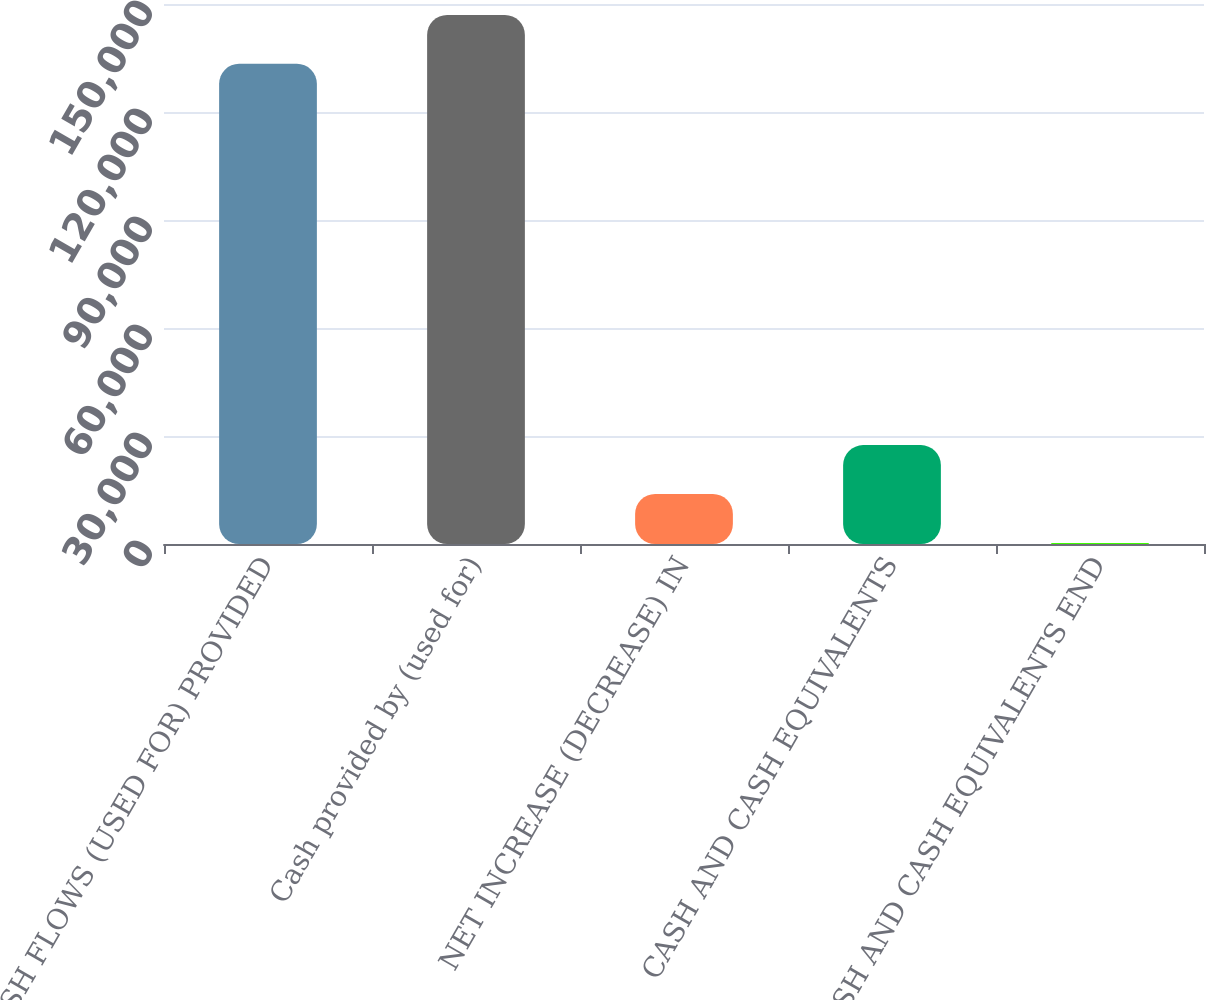Convert chart to OTSL. <chart><loc_0><loc_0><loc_500><loc_500><bar_chart><fcel>CASH FLOWS (USED FOR) PROVIDED<fcel>Cash provided by (used for)<fcel>NET INCREASE (DECREASE) IN<fcel>CASH AND CASH EQUIVALENTS<fcel>CASH AND CASH EQUIVALENTS END<nl><fcel>133393<fcel>146972<fcel>13886.3<fcel>27465.6<fcel>307<nl></chart> 